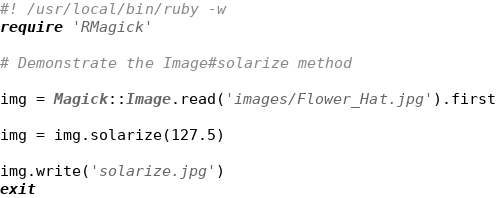<code> <loc_0><loc_0><loc_500><loc_500><_Ruby_>#! /usr/local/bin/ruby -w
require 'RMagick'

# Demonstrate the Image#solarize method

img = Magick::Image.read('images/Flower_Hat.jpg').first

img = img.solarize(127.5)

img.write('solarize.jpg')
exit
</code> 